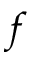<formula> <loc_0><loc_0><loc_500><loc_500>f</formula> 